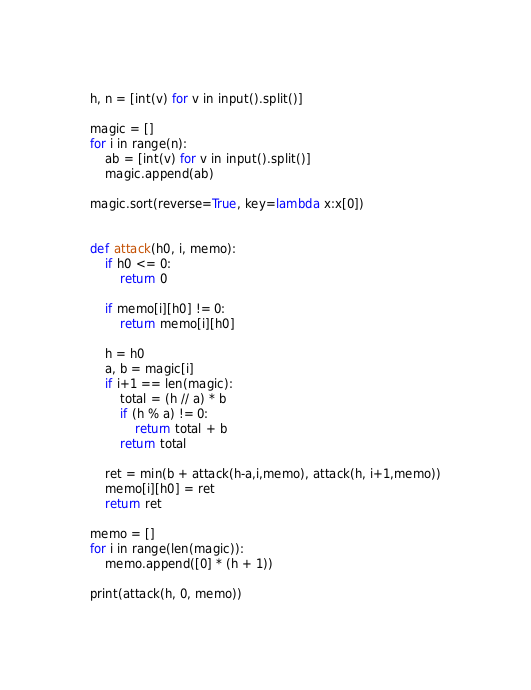Convert code to text. <code><loc_0><loc_0><loc_500><loc_500><_Python_>h, n = [int(v) for v in input().split()]

magic = []
for i in range(n):
    ab = [int(v) for v in input().split()]
    magic.append(ab)

magic.sort(reverse=True, key=lambda x:x[0])


def attack(h0, i, memo):
    if h0 <= 0:
        return 0

    if memo[i][h0] != 0:
        return memo[i][h0]

    h = h0
    a, b = magic[i]
    if i+1 == len(magic):
        total = (h // a) * b
        if (h % a) != 0:
            return total + b
        return total

    ret = min(b + attack(h-a,i,memo), attack(h, i+1,memo))
    memo[i][h0] = ret
    return ret
    
memo = []
for i in range(len(magic)):
    memo.append([0] * (h + 1))

print(attack(h, 0, memo))</code> 